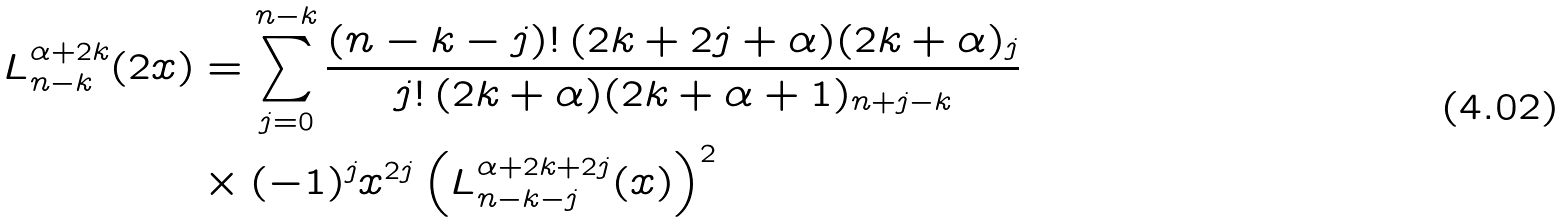Convert formula to latex. <formula><loc_0><loc_0><loc_500><loc_500>L ^ { \alpha + 2 k } _ { n - k } ( 2 x ) & = \sum ^ { n - k } _ { j = 0 } \frac { ( n - k - j ) ! \, ( 2 k + 2 j + \alpha ) ( 2 k + \alpha ) _ { j } } { j ! \, ( 2 k + \alpha ) ( 2 k + \alpha + 1 ) _ { n + j - k } } \\ & \times ( - 1 ) ^ { j } x ^ { 2 j } \left ( L ^ { \alpha + 2 k + 2 j } _ { n - k - j } ( x ) \right ) ^ { 2 }</formula> 